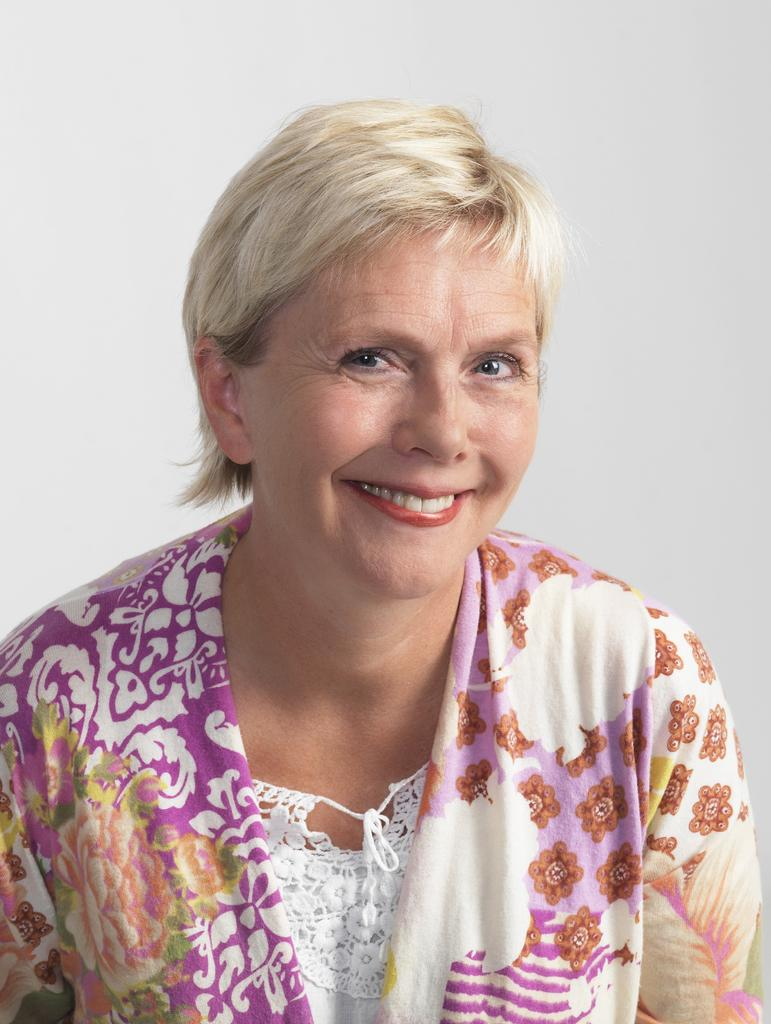What is the main subject of the image? The main subject of the image is a woman. Can you describe the woman's expression in the image? The woman is smiling in the image. What type of cakes did the woman bake for the battle during her trip? There is no mention of a trip, battle, or cakes in the image. The image only shows a woman smiling, so it is not possible to answer that question based on the image. 